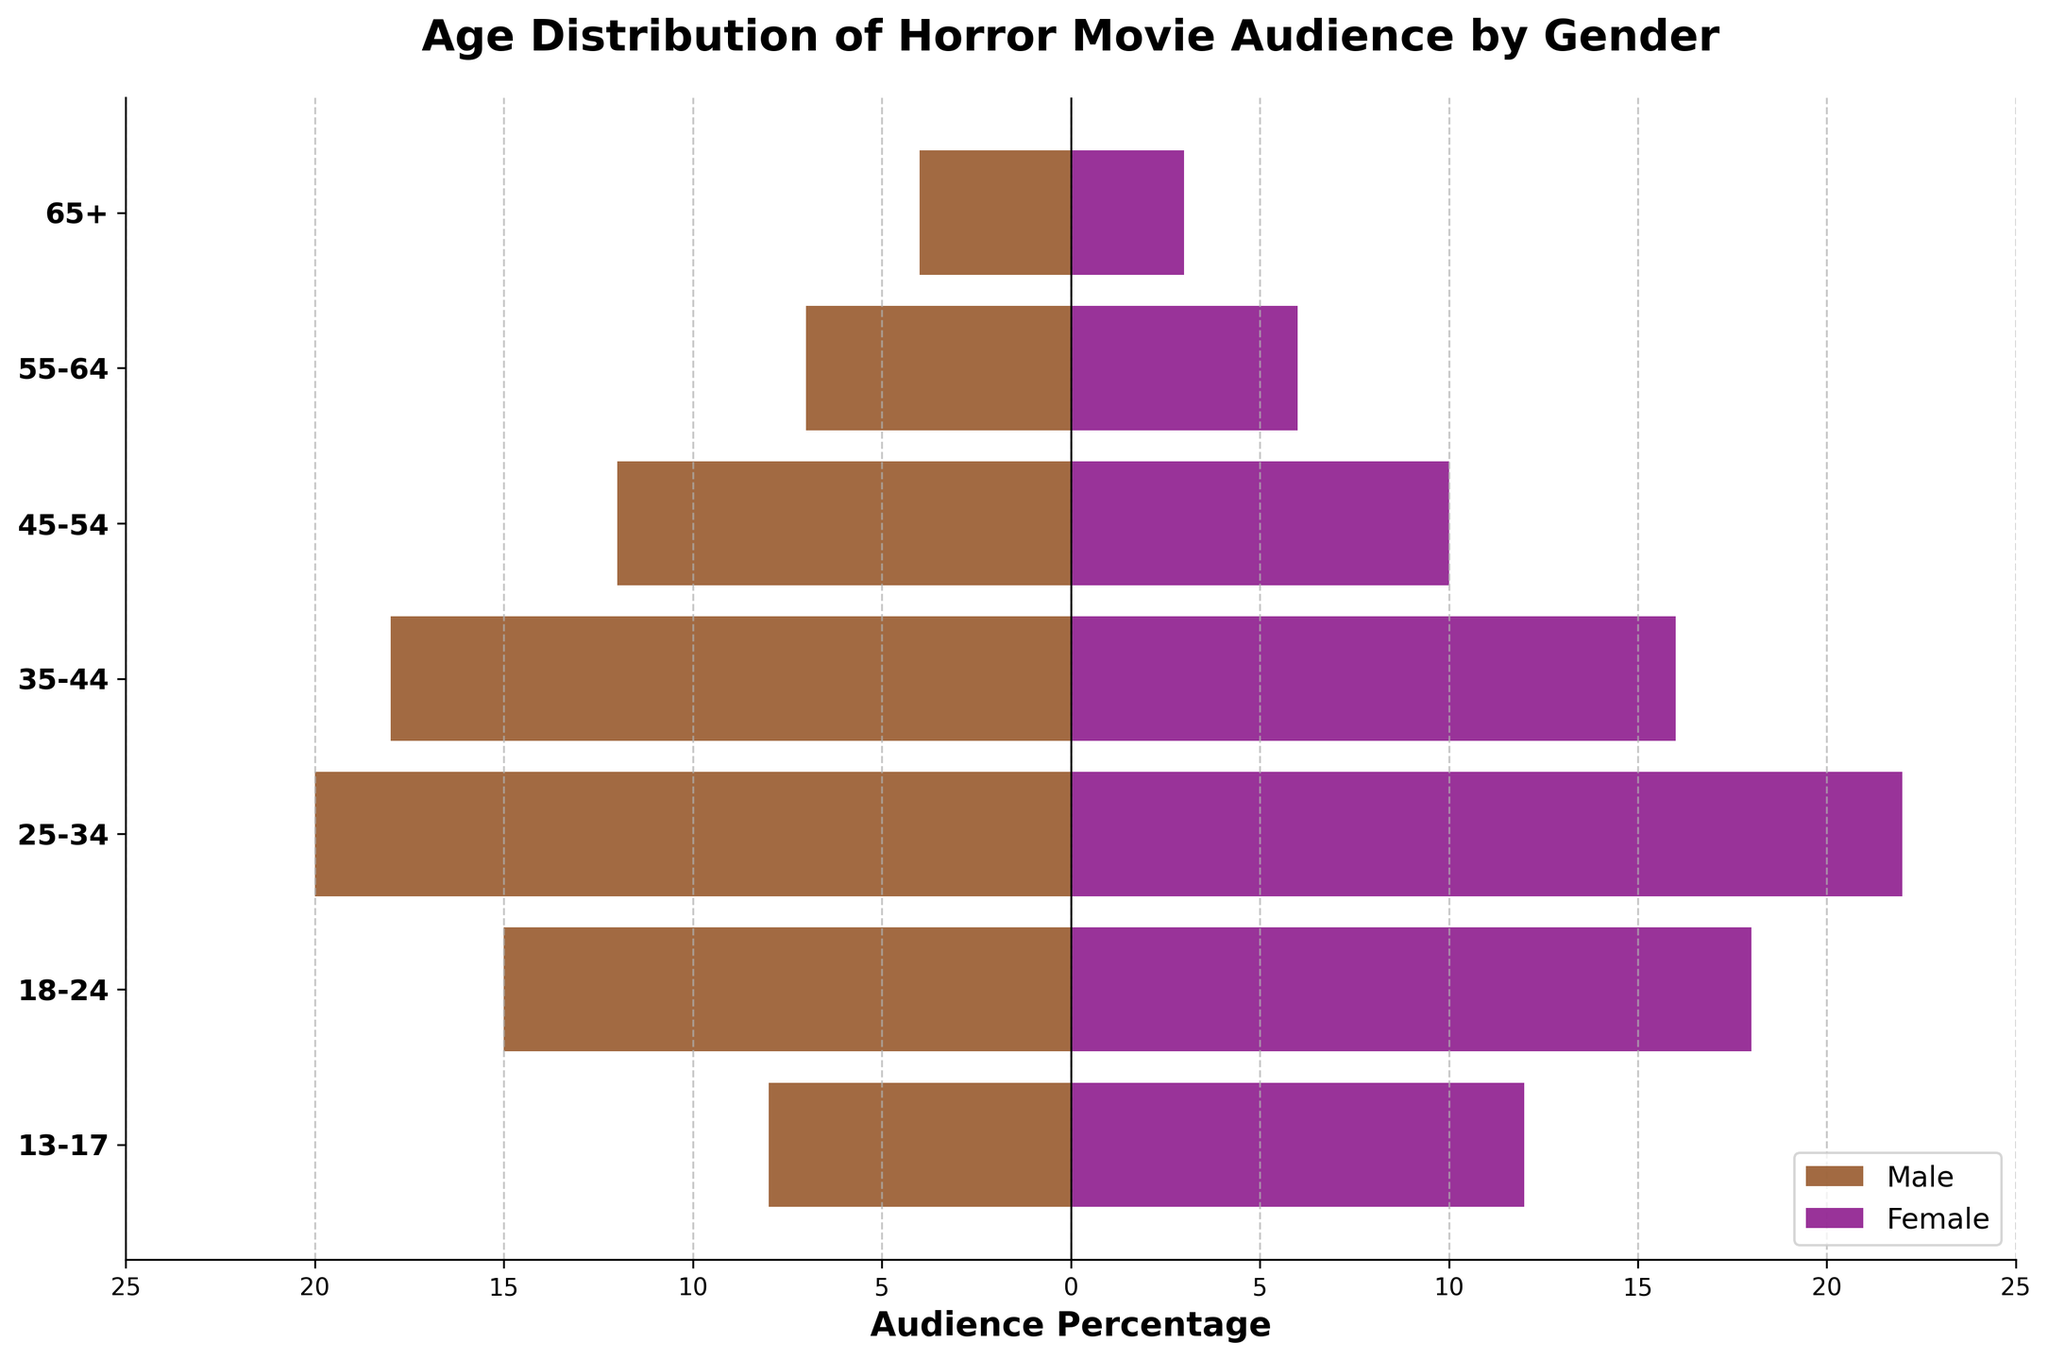What is the title of the figure? The title is located at the top of the figure, and it provides a summary of what the figure represents.
Answer: Age Distribution of Horror Movie Audience by Gender Which age group has the highest number of female horror movie audience members? Look at the bar lengths representing females in each age group and identify the longest one.
Answer: 25-34 How many males are in the 18-24 age group? The number is indicated by the length of the bar for males in the 18-24 age group. The value is also annotated on the bar.
Answer: 15 What is the total number of audience members aged 13-17? Add the number of males and females in the 13-17 age group by looking at the annotated values on the bars. Therefore, 8 males + 12 females = 20.
Answer: 20 Which gender has more audience members in the 45-54 age group? Compare the lengths of the bars for males and females in the 45-54 age group.
Answer: Male How does the number of male audience members aged 25-34 compare to those aged 55-64? Subtract the number of males in the 55-64 age group from those in the 25-34 age group to see the difference: 20 - 7 = 13.
Answer: 13 more in 25-34 For which age group are the audience numbers for males and females most similar? Identify the age group where the lengths of the bars for males and females are closest to each other. This happens in the 35-44 age group, where the numbers are 18 for males and 16 for females.
Answer: 35-44 Which age group has the smallest audience for both genders combined? Determine this by adding the audience values for males and females for each age group and finding the minimum sum. The smallest is in the 65+ age group, which has 4 males + 3 females = 7.
Answer: 65+ 